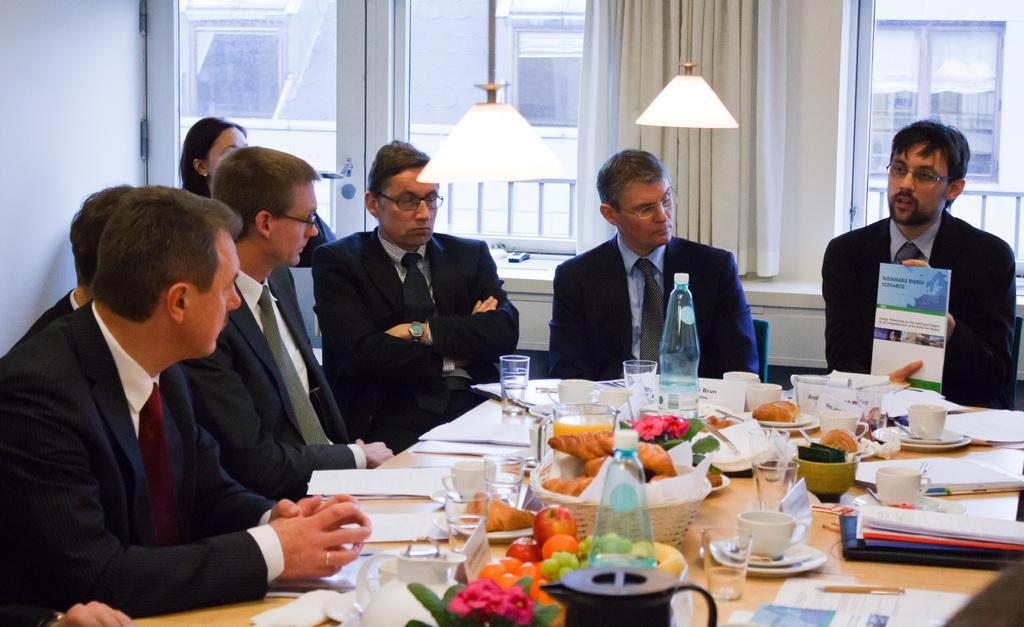How would you summarize this image in a sentence or two? This picture is taken inside the room. In this image, we can see a group of people sitting on the chair in front of the table. On that table, we can see two bottles, glasses, coffee cup, books, papers, bowl with some food and bowl with some fruits and a cloth on the table, pen, plate, water glass, plant with some flower. On the right side, we can see a man sitting on the chair and holding a book in his hand. In the background, we can see few lights, glass windows, hoardings. On the left side, we can see a wall. 